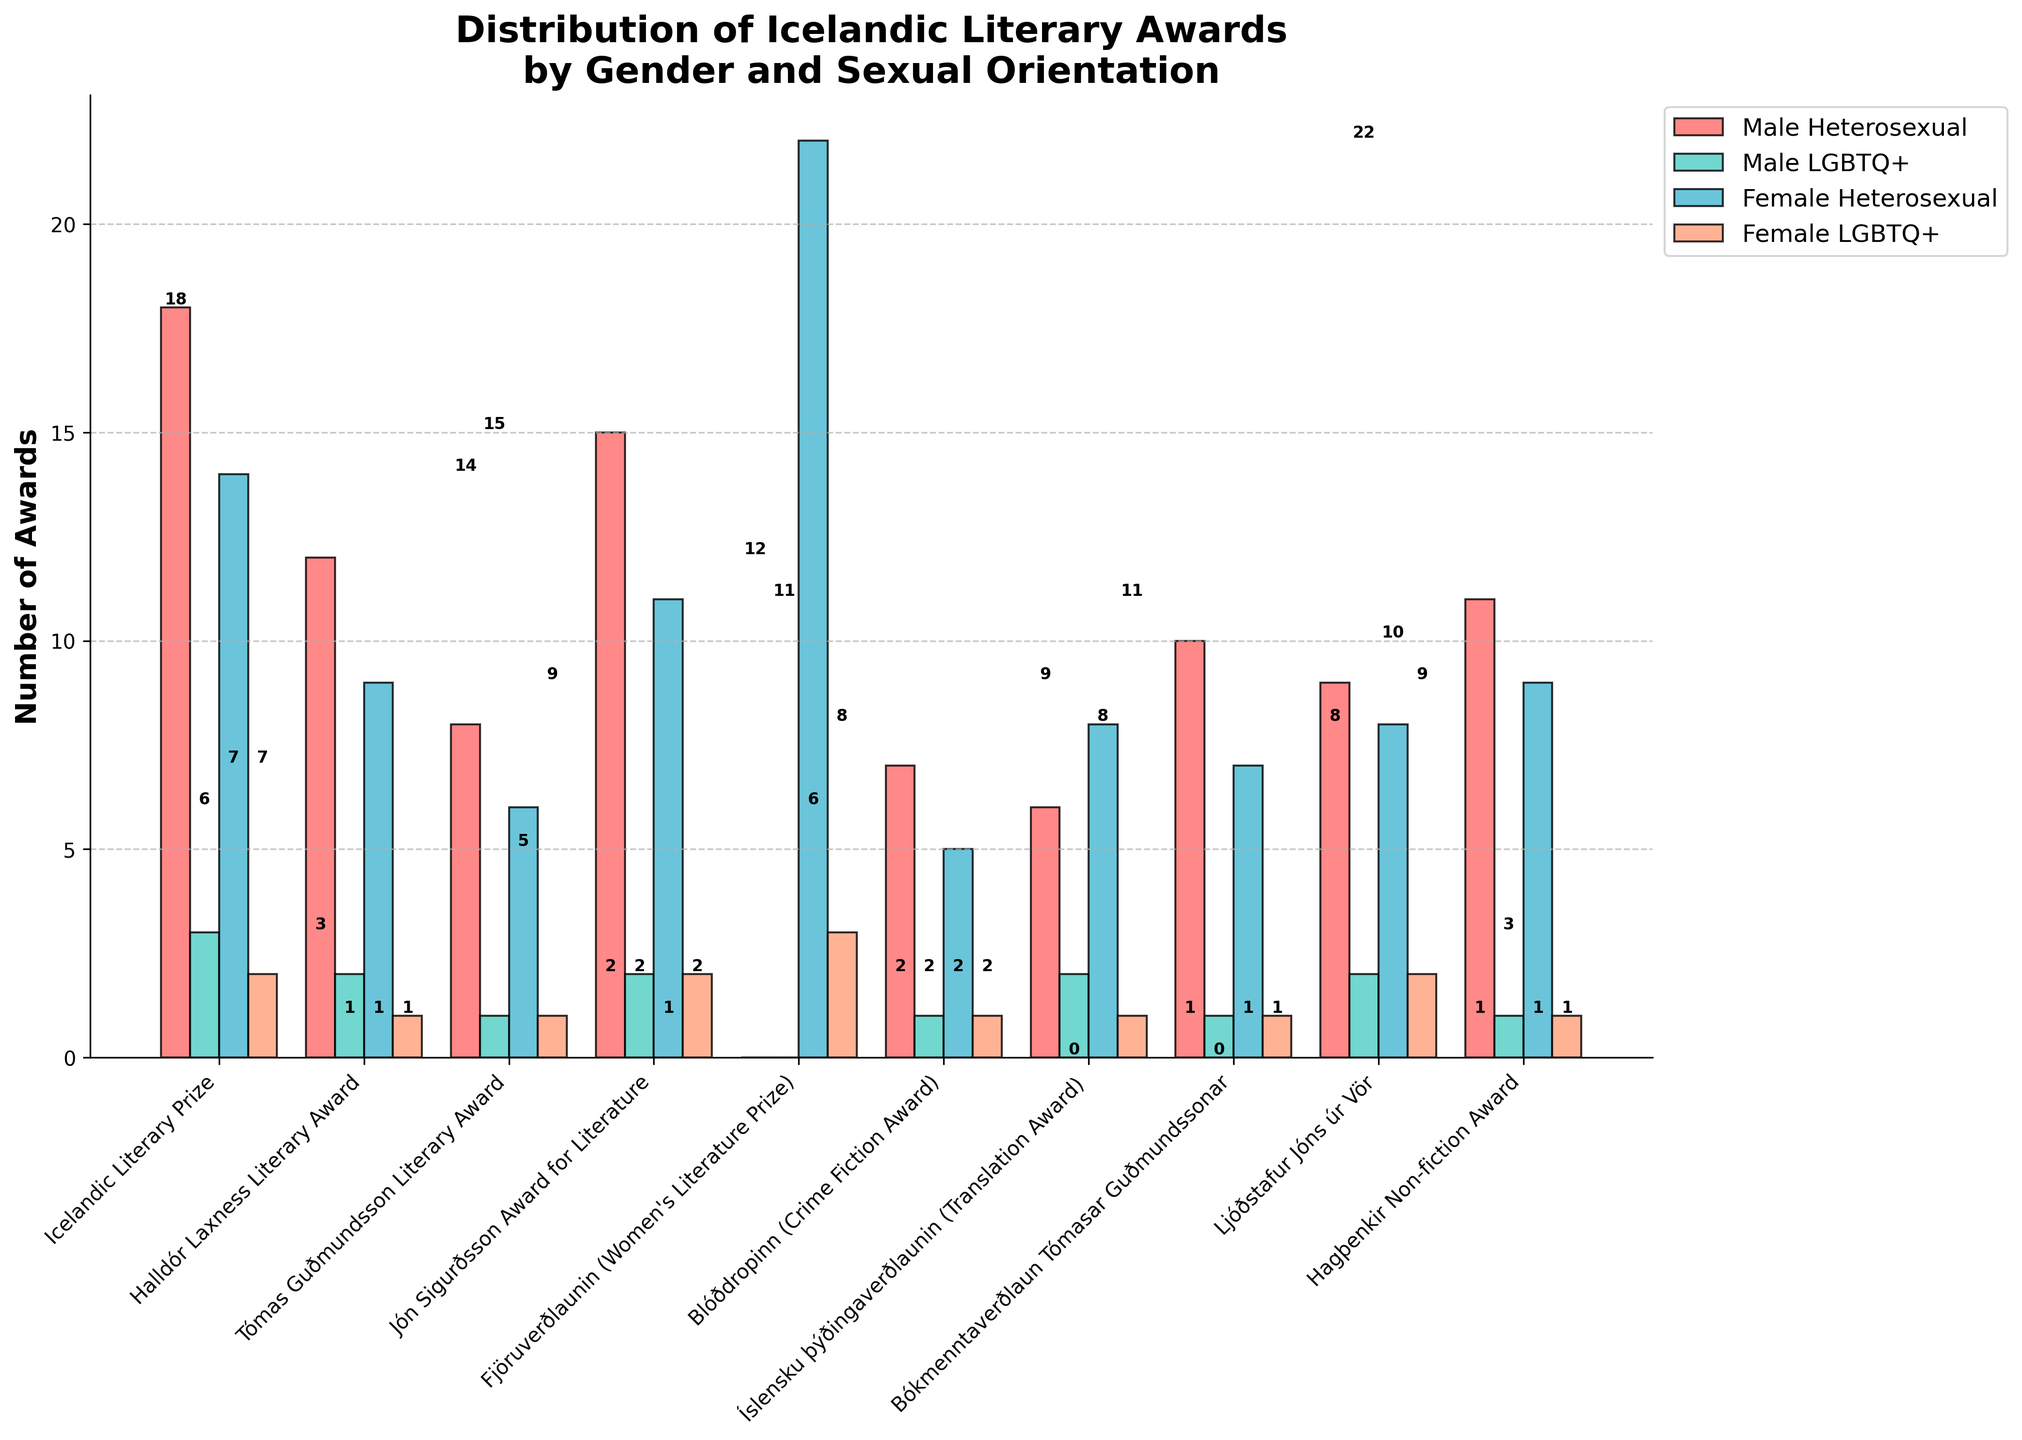What is the total number of awards won by female authors (both heterosexual and LGBTQ+)? To find the total number of awards won by female authors, sum up the awards for 'Female Heterosexual' and 'Female LGBTQ+' across all categories. The values across the categories are (14+2), (9+1), (6+1), (11+2), (22+3), (5+1), (8+1), (7+1), (8+2), (9+1). Adding these values: 16 +10 +7 + 13 + 25 + 6 + 9 + 8 + 10 + 10 = 114
Answer: 114 Which award has the highest number of total recipients, and what is that total? To find this, sum up all categories (Male Heterosexual, Male LGBTQ+, Female Heterosexual, Female LGBTQ+) for each award, and identify the highest. For example: Icelandic Literary Prize (18+3+14+2=37), Halldór Laxness Literary Award (12+2+9+1=24), etc. The highest sum is for the Icelandic Literary Prize with a total of 37.
Answer: Icelandic Literary Prize, 37 Which group has won the fewest awards for the Blóðdropinn (Crime Fiction Award)? Examine the bar heights for the Blóðdropinn award under each group (Male Heterosexual, Male LGBTQ+, Female Heterosexual, Female LGBTQ+). The values are (7, 1, 5, 1). The smallest values are 1 and there are two groups.
Answer: Male LGBTQ+ and Female LGBTQ+ How many more awards have Male Heterosexual authors won compared to Female Heterosexual authors in the Jón Sigurðsson Award for Literature? Compare the values for Male Heterosexual and Female Heterosexual in the Jón Sigurðsson Award (15 for Male Heterosexual, 11 for Female Heterosexual). The difference is 15 - 11 = 4.
Answer: 4 What percentage of the total 'Fjöruverðlaunin (Women's Literature Prize)' awards have been won by Female LGBTQ+ authors? For the 'Fjöruverðlaunin' award, Female LGBTQ+ authors won 3 awards out of a total of (22+3)=25 awards. So, the percentage is (3/25)*100 = 12%.
Answer: 12% Which gender and orientation category is represented with the color green in the bar chart? Visually identify the bar color in the graph. According to the description, the colors are in the order: red, green, blue, salmon. Thus, the second category is represented in green.
Answer: Male LGBTQ+ Which award has been won by exactly three Female LGBTQ+ authors? Look at the heights of the bars for the Female LGBTQ+ category and identify the ones showing the number 3. This is seen for the Fjöruverðlaunin (Women's Literature Prize).
Answer: Fjöruverðlaunin (Women's Literature Prize) What is the difference in the number of awards won by Male Heterosexual authors and Female LGBTQ+ authors, across all awards? Sum the number of awards won by Male Heterosexual across all categories: 18+12+8+15+0+7+6+10+9+11 = 96. Do the same for Female LGBTQ+: 2+1+1+2+3+1+1+1+2+1 = 15. The difference is 96 - 15 = 81.
Answer: 81 